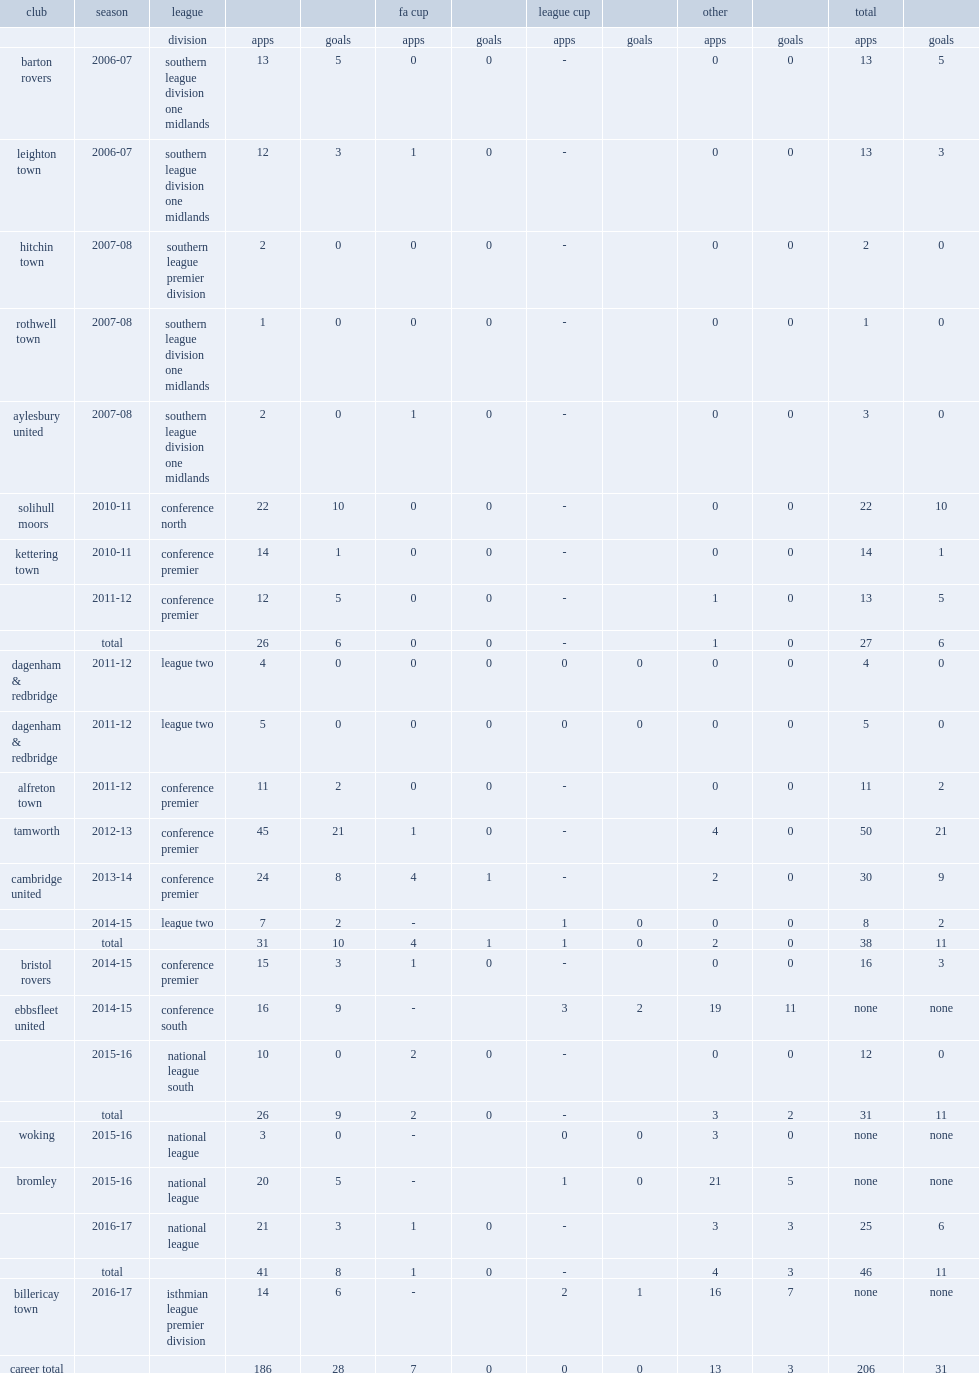Which club did cunnington play for in 2011-12? Dagenham & redbridge. 